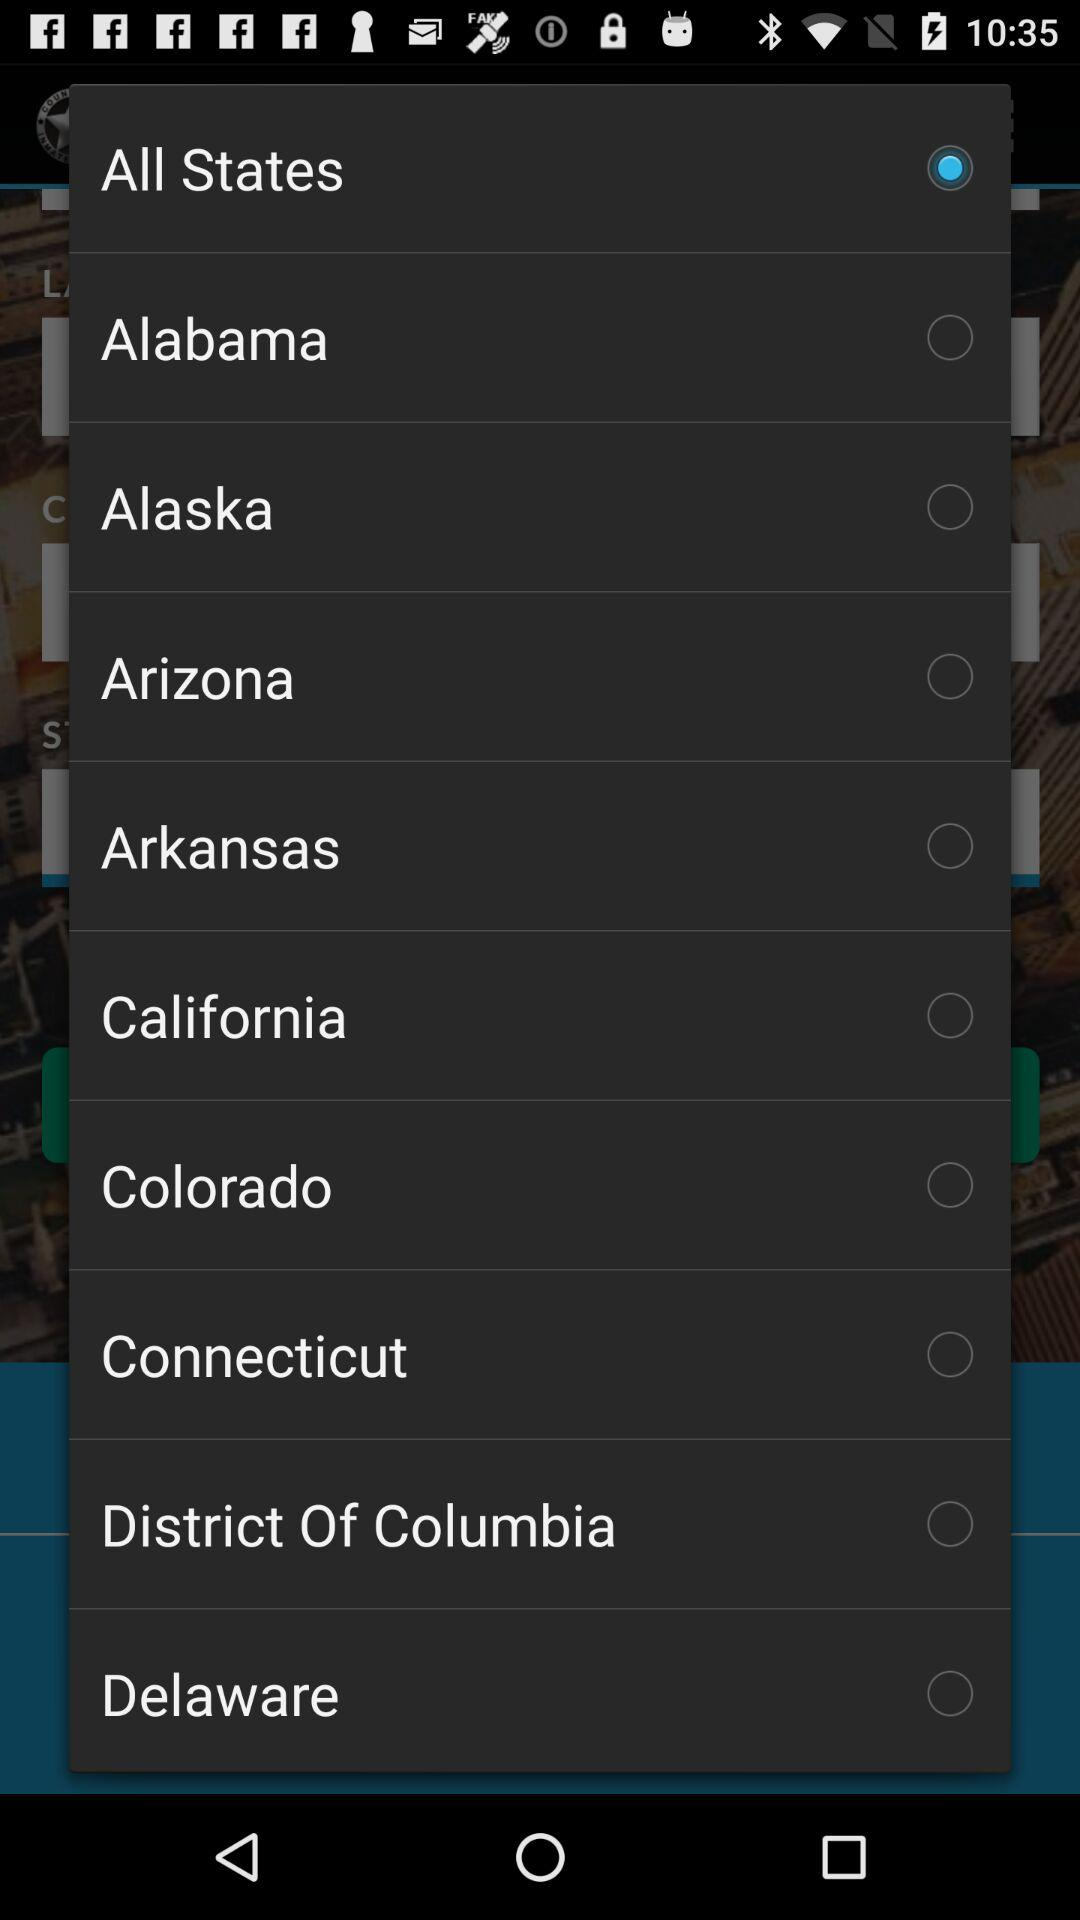Is "Arizona" selected or not? "Arizona" is not selected. 